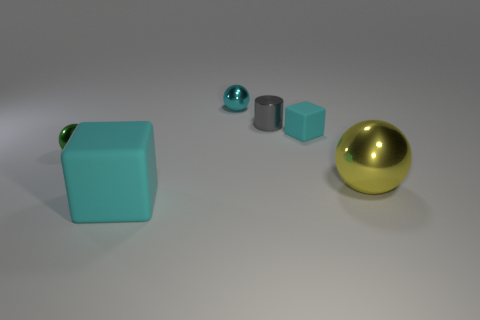Subtract all green metallic spheres. How many spheres are left? 2 Subtract all red balls. Subtract all purple cylinders. How many balls are left? 3 Add 1 small gray cylinders. How many objects exist? 7 Subtract all cylinders. How many objects are left? 5 Subtract all small yellow blocks. Subtract all big metallic things. How many objects are left? 5 Add 5 tiny cyan metal balls. How many tiny cyan metal balls are left? 6 Add 5 small gray metal cylinders. How many small gray metal cylinders exist? 6 Subtract 0 purple balls. How many objects are left? 6 